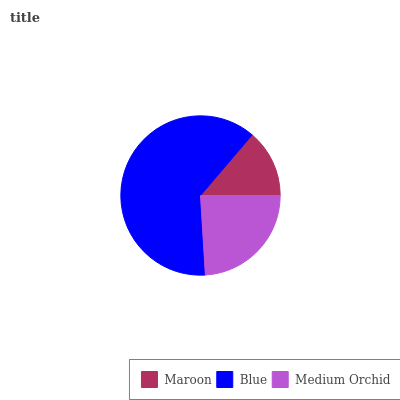Is Maroon the minimum?
Answer yes or no. Yes. Is Blue the maximum?
Answer yes or no. Yes. Is Medium Orchid the minimum?
Answer yes or no. No. Is Medium Orchid the maximum?
Answer yes or no. No. Is Blue greater than Medium Orchid?
Answer yes or no. Yes. Is Medium Orchid less than Blue?
Answer yes or no. Yes. Is Medium Orchid greater than Blue?
Answer yes or no. No. Is Blue less than Medium Orchid?
Answer yes or no. No. Is Medium Orchid the high median?
Answer yes or no. Yes. Is Medium Orchid the low median?
Answer yes or no. Yes. Is Maroon the high median?
Answer yes or no. No. Is Blue the low median?
Answer yes or no. No. 